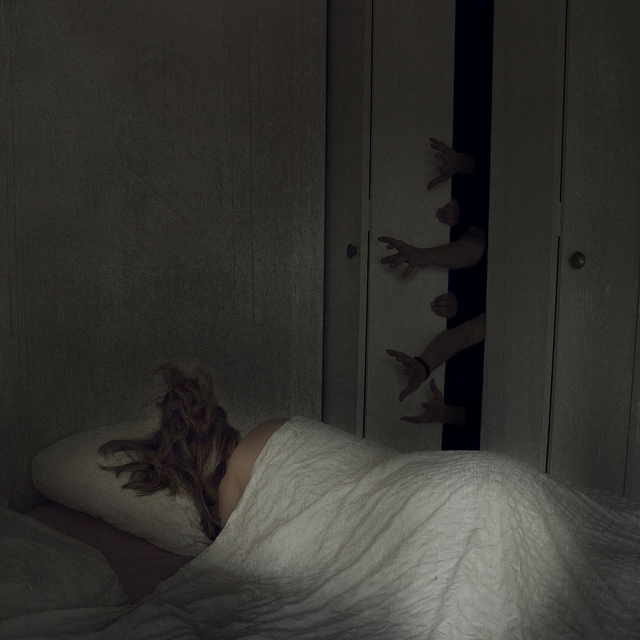<image>What is one here head? It is unclear what is on her head. It could be hair, a wig, or even snakes. What is one here head? I don't know what is on her head. It can be hair, wig or snakes. 